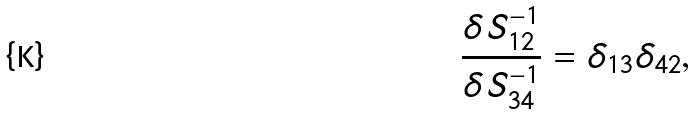Convert formula to latex. <formula><loc_0><loc_0><loc_500><loc_500>\frac { \delta S _ { 1 2 } ^ { - 1 } } { \delta S _ { 3 4 } ^ { - 1 } } = \delta _ { 1 3 } \delta _ { 4 2 } ,</formula> 